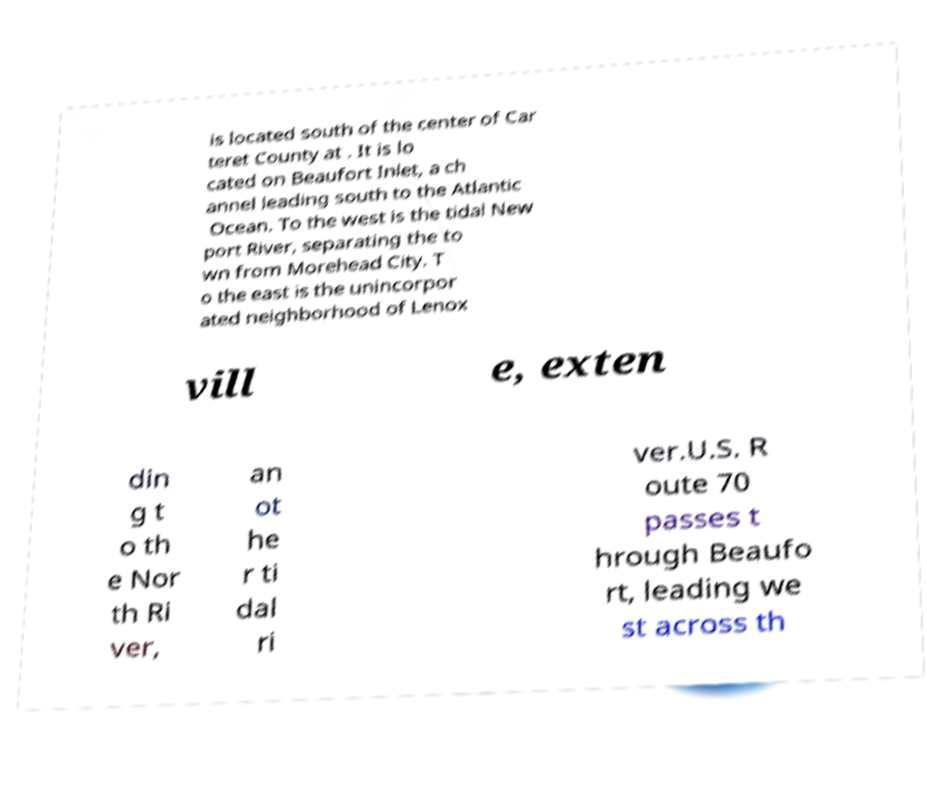I need the written content from this picture converted into text. Can you do that? is located south of the center of Car teret County at . It is lo cated on Beaufort Inlet, a ch annel leading south to the Atlantic Ocean. To the west is the tidal New port River, separating the to wn from Morehead City. T o the east is the unincorpor ated neighborhood of Lenox vill e, exten din g t o th e Nor th Ri ver, an ot he r ti dal ri ver.U.S. R oute 70 passes t hrough Beaufo rt, leading we st across th 